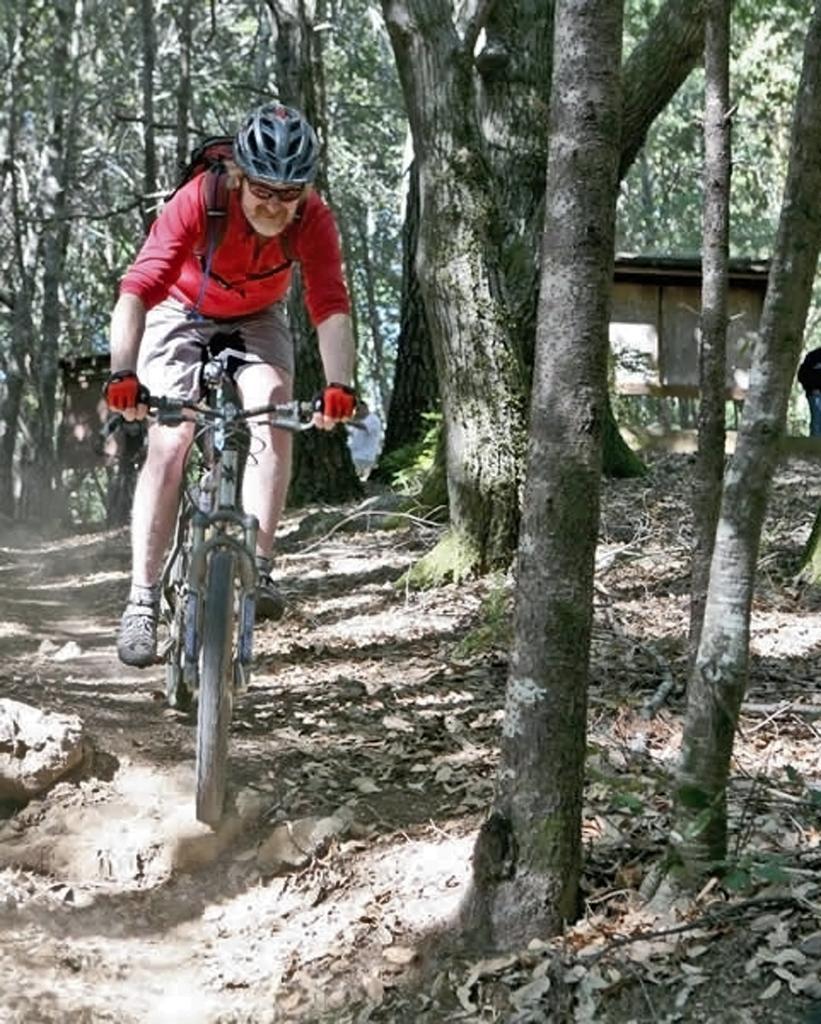In one or two sentences, can you explain what this image depicts? In the image there is a person with helmet is riding a bicycle. On the ground there are dry leaves and also there are few rocks. In the background there are many trees and also there is a room with walls and roofs. 